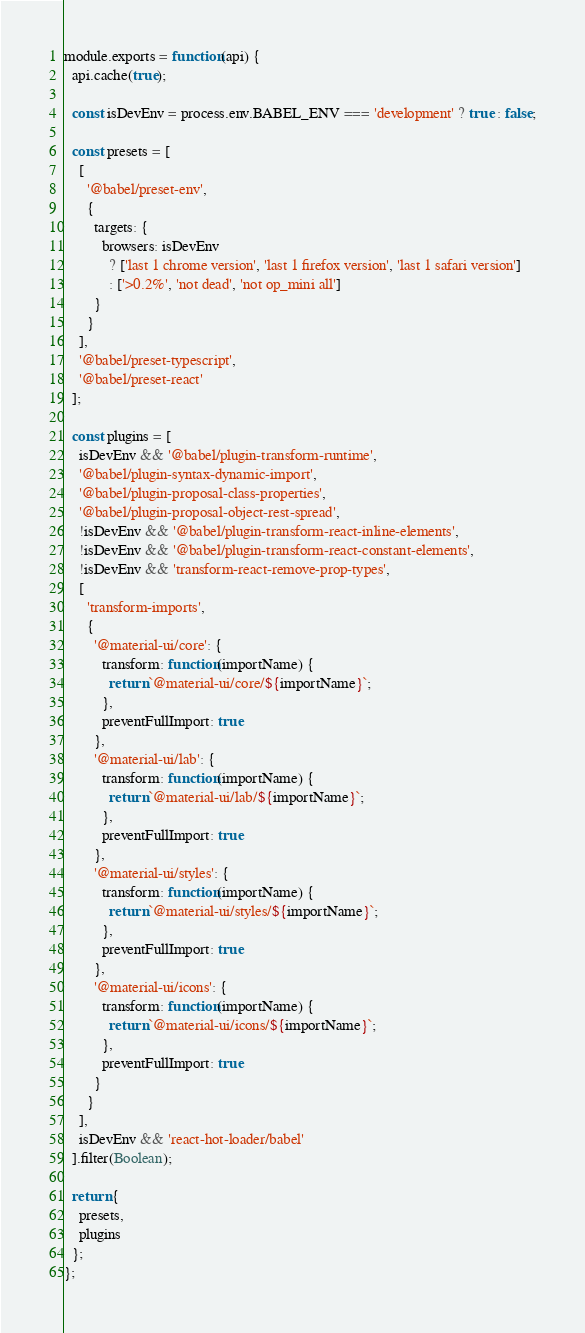<code> <loc_0><loc_0><loc_500><loc_500><_JavaScript_>module.exports = function(api) {
  api.cache(true);

  const isDevEnv = process.env.BABEL_ENV === 'development' ? true : false;

  const presets = [
    [
      '@babel/preset-env',
      {
        targets: {
          browsers: isDevEnv
            ? ['last 1 chrome version', 'last 1 firefox version', 'last 1 safari version']
            : ['>0.2%', 'not dead', 'not op_mini all']
        }
      }
    ],
    '@babel/preset-typescript',
    '@babel/preset-react'
  ];

  const plugins = [
    isDevEnv && '@babel/plugin-transform-runtime',
    '@babel/plugin-syntax-dynamic-import',
    '@babel/plugin-proposal-class-properties',
    '@babel/plugin-proposal-object-rest-spread',
    !isDevEnv && '@babel/plugin-transform-react-inline-elements',
    !isDevEnv && '@babel/plugin-transform-react-constant-elements',
    !isDevEnv && 'transform-react-remove-prop-types',
    [
      'transform-imports',
      {
        '@material-ui/core': {
          transform: function(importName) {
            return `@material-ui/core/${importName}`;
          },
          preventFullImport: true
        },
        '@material-ui/lab': {
          transform: function(importName) {
            return `@material-ui/lab/${importName}`;
          },
          preventFullImport: true
        },
        '@material-ui/styles': {
          transform: function(importName) {
            return `@material-ui/styles/${importName}`;
          },
          preventFullImport: true
        },
        '@material-ui/icons': {
          transform: function(importName) {
            return `@material-ui/icons/${importName}`;
          },
          preventFullImport: true
        }
      }
    ],
    isDevEnv && 'react-hot-loader/babel'
  ].filter(Boolean);

  return {
    presets,
    plugins
  };
};
</code> 